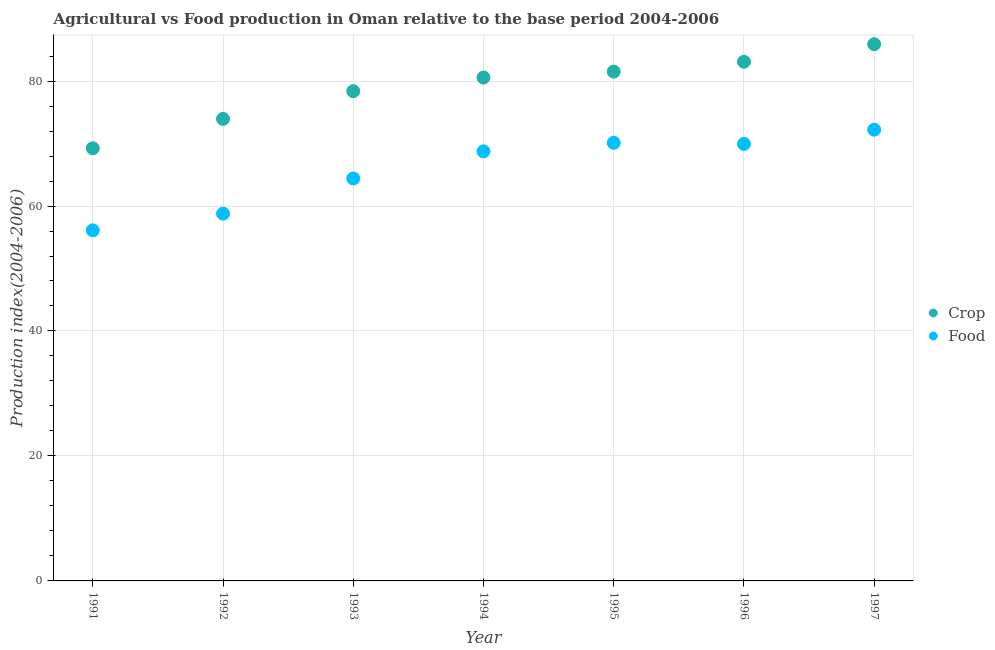How many different coloured dotlines are there?
Offer a terse response. 2. What is the food production index in 1996?
Give a very brief answer. 69.94. Across all years, what is the maximum food production index?
Offer a very short reply. 72.22. Across all years, what is the minimum crop production index?
Provide a succinct answer. 69.24. In which year was the food production index maximum?
Keep it short and to the point. 1997. What is the total crop production index in the graph?
Provide a succinct answer. 552.62. What is the difference between the crop production index in 1995 and that in 1997?
Your answer should be compact. -4.39. What is the difference between the food production index in 1994 and the crop production index in 1995?
Provide a short and direct response. -12.76. What is the average food production index per year?
Offer a terse response. 65.76. In the year 1995, what is the difference between the food production index and crop production index?
Ensure brevity in your answer.  -11.39. What is the ratio of the crop production index in 1993 to that in 1995?
Your answer should be very brief. 0.96. Is the crop production index in 1992 less than that in 1997?
Provide a succinct answer. Yes. Is the difference between the food production index in 1991 and 1992 greater than the difference between the crop production index in 1991 and 1992?
Make the answer very short. Yes. What is the difference between the highest and the second highest crop production index?
Ensure brevity in your answer.  2.81. What is the difference between the highest and the lowest food production index?
Keep it short and to the point. 16.11. Does the crop production index monotonically increase over the years?
Your answer should be compact. Yes. Is the crop production index strictly less than the food production index over the years?
Your answer should be compact. No. How many dotlines are there?
Your answer should be very brief. 2. How many legend labels are there?
Ensure brevity in your answer.  2. What is the title of the graph?
Offer a terse response. Agricultural vs Food production in Oman relative to the base period 2004-2006. What is the label or title of the Y-axis?
Your answer should be very brief. Production index(2004-2006). What is the Production index(2004-2006) of Crop in 1991?
Provide a succinct answer. 69.24. What is the Production index(2004-2006) in Food in 1991?
Your answer should be very brief. 56.11. What is the Production index(2004-2006) in Crop in 1992?
Your answer should be very brief. 73.94. What is the Production index(2004-2006) of Food in 1992?
Provide a succinct answer. 58.78. What is the Production index(2004-2006) of Crop in 1993?
Ensure brevity in your answer.  78.38. What is the Production index(2004-2006) of Food in 1993?
Make the answer very short. 64.41. What is the Production index(2004-2006) in Crop in 1994?
Your answer should be very brief. 80.56. What is the Production index(2004-2006) of Food in 1994?
Provide a succinct answer. 68.75. What is the Production index(2004-2006) of Crop in 1995?
Ensure brevity in your answer.  81.51. What is the Production index(2004-2006) in Food in 1995?
Your answer should be compact. 70.12. What is the Production index(2004-2006) of Crop in 1996?
Your response must be concise. 83.09. What is the Production index(2004-2006) in Food in 1996?
Keep it short and to the point. 69.94. What is the Production index(2004-2006) in Crop in 1997?
Provide a short and direct response. 85.9. What is the Production index(2004-2006) of Food in 1997?
Offer a terse response. 72.22. Across all years, what is the maximum Production index(2004-2006) in Crop?
Make the answer very short. 85.9. Across all years, what is the maximum Production index(2004-2006) of Food?
Give a very brief answer. 72.22. Across all years, what is the minimum Production index(2004-2006) in Crop?
Give a very brief answer. 69.24. Across all years, what is the minimum Production index(2004-2006) of Food?
Ensure brevity in your answer.  56.11. What is the total Production index(2004-2006) of Crop in the graph?
Keep it short and to the point. 552.62. What is the total Production index(2004-2006) of Food in the graph?
Give a very brief answer. 460.33. What is the difference between the Production index(2004-2006) in Food in 1991 and that in 1992?
Ensure brevity in your answer.  -2.67. What is the difference between the Production index(2004-2006) of Crop in 1991 and that in 1993?
Your answer should be very brief. -9.14. What is the difference between the Production index(2004-2006) in Crop in 1991 and that in 1994?
Provide a succinct answer. -11.32. What is the difference between the Production index(2004-2006) in Food in 1991 and that in 1994?
Keep it short and to the point. -12.64. What is the difference between the Production index(2004-2006) of Crop in 1991 and that in 1995?
Your response must be concise. -12.27. What is the difference between the Production index(2004-2006) of Food in 1991 and that in 1995?
Your answer should be very brief. -14.01. What is the difference between the Production index(2004-2006) of Crop in 1991 and that in 1996?
Ensure brevity in your answer.  -13.85. What is the difference between the Production index(2004-2006) in Food in 1991 and that in 1996?
Your answer should be compact. -13.83. What is the difference between the Production index(2004-2006) in Crop in 1991 and that in 1997?
Offer a very short reply. -16.66. What is the difference between the Production index(2004-2006) of Food in 1991 and that in 1997?
Your response must be concise. -16.11. What is the difference between the Production index(2004-2006) of Crop in 1992 and that in 1993?
Make the answer very short. -4.44. What is the difference between the Production index(2004-2006) in Food in 1992 and that in 1993?
Provide a short and direct response. -5.63. What is the difference between the Production index(2004-2006) in Crop in 1992 and that in 1994?
Ensure brevity in your answer.  -6.62. What is the difference between the Production index(2004-2006) of Food in 1992 and that in 1994?
Your response must be concise. -9.97. What is the difference between the Production index(2004-2006) of Crop in 1992 and that in 1995?
Provide a short and direct response. -7.57. What is the difference between the Production index(2004-2006) of Food in 1992 and that in 1995?
Ensure brevity in your answer.  -11.34. What is the difference between the Production index(2004-2006) in Crop in 1992 and that in 1996?
Ensure brevity in your answer.  -9.15. What is the difference between the Production index(2004-2006) in Food in 1992 and that in 1996?
Provide a short and direct response. -11.16. What is the difference between the Production index(2004-2006) in Crop in 1992 and that in 1997?
Your response must be concise. -11.96. What is the difference between the Production index(2004-2006) of Food in 1992 and that in 1997?
Your answer should be very brief. -13.44. What is the difference between the Production index(2004-2006) in Crop in 1993 and that in 1994?
Offer a terse response. -2.18. What is the difference between the Production index(2004-2006) of Food in 1993 and that in 1994?
Offer a terse response. -4.34. What is the difference between the Production index(2004-2006) of Crop in 1993 and that in 1995?
Provide a succinct answer. -3.13. What is the difference between the Production index(2004-2006) of Food in 1993 and that in 1995?
Your response must be concise. -5.71. What is the difference between the Production index(2004-2006) of Crop in 1993 and that in 1996?
Ensure brevity in your answer.  -4.71. What is the difference between the Production index(2004-2006) of Food in 1993 and that in 1996?
Keep it short and to the point. -5.53. What is the difference between the Production index(2004-2006) of Crop in 1993 and that in 1997?
Offer a terse response. -7.52. What is the difference between the Production index(2004-2006) in Food in 1993 and that in 1997?
Your answer should be compact. -7.81. What is the difference between the Production index(2004-2006) in Crop in 1994 and that in 1995?
Keep it short and to the point. -0.95. What is the difference between the Production index(2004-2006) in Food in 1994 and that in 1995?
Offer a terse response. -1.37. What is the difference between the Production index(2004-2006) in Crop in 1994 and that in 1996?
Offer a terse response. -2.53. What is the difference between the Production index(2004-2006) in Food in 1994 and that in 1996?
Provide a succinct answer. -1.19. What is the difference between the Production index(2004-2006) in Crop in 1994 and that in 1997?
Make the answer very short. -5.34. What is the difference between the Production index(2004-2006) in Food in 1994 and that in 1997?
Keep it short and to the point. -3.47. What is the difference between the Production index(2004-2006) in Crop in 1995 and that in 1996?
Offer a very short reply. -1.58. What is the difference between the Production index(2004-2006) of Food in 1995 and that in 1996?
Offer a terse response. 0.18. What is the difference between the Production index(2004-2006) of Crop in 1995 and that in 1997?
Give a very brief answer. -4.39. What is the difference between the Production index(2004-2006) in Food in 1995 and that in 1997?
Offer a very short reply. -2.1. What is the difference between the Production index(2004-2006) of Crop in 1996 and that in 1997?
Your answer should be very brief. -2.81. What is the difference between the Production index(2004-2006) in Food in 1996 and that in 1997?
Make the answer very short. -2.28. What is the difference between the Production index(2004-2006) of Crop in 1991 and the Production index(2004-2006) of Food in 1992?
Offer a terse response. 10.46. What is the difference between the Production index(2004-2006) in Crop in 1991 and the Production index(2004-2006) in Food in 1993?
Keep it short and to the point. 4.83. What is the difference between the Production index(2004-2006) of Crop in 1991 and the Production index(2004-2006) of Food in 1994?
Provide a short and direct response. 0.49. What is the difference between the Production index(2004-2006) in Crop in 1991 and the Production index(2004-2006) in Food in 1995?
Offer a terse response. -0.88. What is the difference between the Production index(2004-2006) of Crop in 1991 and the Production index(2004-2006) of Food in 1997?
Make the answer very short. -2.98. What is the difference between the Production index(2004-2006) in Crop in 1992 and the Production index(2004-2006) in Food in 1993?
Keep it short and to the point. 9.53. What is the difference between the Production index(2004-2006) of Crop in 1992 and the Production index(2004-2006) of Food in 1994?
Your response must be concise. 5.19. What is the difference between the Production index(2004-2006) in Crop in 1992 and the Production index(2004-2006) in Food in 1995?
Your response must be concise. 3.82. What is the difference between the Production index(2004-2006) in Crop in 1992 and the Production index(2004-2006) in Food in 1996?
Offer a very short reply. 4. What is the difference between the Production index(2004-2006) in Crop in 1992 and the Production index(2004-2006) in Food in 1997?
Offer a terse response. 1.72. What is the difference between the Production index(2004-2006) of Crop in 1993 and the Production index(2004-2006) of Food in 1994?
Make the answer very short. 9.63. What is the difference between the Production index(2004-2006) of Crop in 1993 and the Production index(2004-2006) of Food in 1995?
Your answer should be compact. 8.26. What is the difference between the Production index(2004-2006) of Crop in 1993 and the Production index(2004-2006) of Food in 1996?
Provide a succinct answer. 8.44. What is the difference between the Production index(2004-2006) in Crop in 1993 and the Production index(2004-2006) in Food in 1997?
Give a very brief answer. 6.16. What is the difference between the Production index(2004-2006) in Crop in 1994 and the Production index(2004-2006) in Food in 1995?
Make the answer very short. 10.44. What is the difference between the Production index(2004-2006) of Crop in 1994 and the Production index(2004-2006) of Food in 1996?
Ensure brevity in your answer.  10.62. What is the difference between the Production index(2004-2006) in Crop in 1994 and the Production index(2004-2006) in Food in 1997?
Provide a short and direct response. 8.34. What is the difference between the Production index(2004-2006) of Crop in 1995 and the Production index(2004-2006) of Food in 1996?
Ensure brevity in your answer.  11.57. What is the difference between the Production index(2004-2006) of Crop in 1995 and the Production index(2004-2006) of Food in 1997?
Your response must be concise. 9.29. What is the difference between the Production index(2004-2006) in Crop in 1996 and the Production index(2004-2006) in Food in 1997?
Offer a terse response. 10.87. What is the average Production index(2004-2006) of Crop per year?
Offer a terse response. 78.95. What is the average Production index(2004-2006) in Food per year?
Offer a very short reply. 65.76. In the year 1991, what is the difference between the Production index(2004-2006) of Crop and Production index(2004-2006) of Food?
Make the answer very short. 13.13. In the year 1992, what is the difference between the Production index(2004-2006) in Crop and Production index(2004-2006) in Food?
Offer a terse response. 15.16. In the year 1993, what is the difference between the Production index(2004-2006) of Crop and Production index(2004-2006) of Food?
Your answer should be very brief. 13.97. In the year 1994, what is the difference between the Production index(2004-2006) in Crop and Production index(2004-2006) in Food?
Make the answer very short. 11.81. In the year 1995, what is the difference between the Production index(2004-2006) in Crop and Production index(2004-2006) in Food?
Your response must be concise. 11.39. In the year 1996, what is the difference between the Production index(2004-2006) of Crop and Production index(2004-2006) of Food?
Provide a short and direct response. 13.15. In the year 1997, what is the difference between the Production index(2004-2006) of Crop and Production index(2004-2006) of Food?
Your answer should be compact. 13.68. What is the ratio of the Production index(2004-2006) of Crop in 1991 to that in 1992?
Ensure brevity in your answer.  0.94. What is the ratio of the Production index(2004-2006) in Food in 1991 to that in 1992?
Make the answer very short. 0.95. What is the ratio of the Production index(2004-2006) of Crop in 1991 to that in 1993?
Your answer should be compact. 0.88. What is the ratio of the Production index(2004-2006) of Food in 1991 to that in 1993?
Provide a short and direct response. 0.87. What is the ratio of the Production index(2004-2006) in Crop in 1991 to that in 1994?
Give a very brief answer. 0.86. What is the ratio of the Production index(2004-2006) of Food in 1991 to that in 1994?
Make the answer very short. 0.82. What is the ratio of the Production index(2004-2006) in Crop in 1991 to that in 1995?
Keep it short and to the point. 0.85. What is the ratio of the Production index(2004-2006) in Food in 1991 to that in 1995?
Offer a very short reply. 0.8. What is the ratio of the Production index(2004-2006) of Crop in 1991 to that in 1996?
Your answer should be very brief. 0.83. What is the ratio of the Production index(2004-2006) in Food in 1991 to that in 1996?
Offer a terse response. 0.8. What is the ratio of the Production index(2004-2006) of Crop in 1991 to that in 1997?
Offer a very short reply. 0.81. What is the ratio of the Production index(2004-2006) of Food in 1991 to that in 1997?
Make the answer very short. 0.78. What is the ratio of the Production index(2004-2006) in Crop in 1992 to that in 1993?
Offer a very short reply. 0.94. What is the ratio of the Production index(2004-2006) in Food in 1992 to that in 1993?
Provide a short and direct response. 0.91. What is the ratio of the Production index(2004-2006) in Crop in 1992 to that in 1994?
Your response must be concise. 0.92. What is the ratio of the Production index(2004-2006) in Food in 1992 to that in 1994?
Keep it short and to the point. 0.85. What is the ratio of the Production index(2004-2006) in Crop in 1992 to that in 1995?
Your response must be concise. 0.91. What is the ratio of the Production index(2004-2006) in Food in 1992 to that in 1995?
Provide a succinct answer. 0.84. What is the ratio of the Production index(2004-2006) of Crop in 1992 to that in 1996?
Give a very brief answer. 0.89. What is the ratio of the Production index(2004-2006) in Food in 1992 to that in 1996?
Provide a short and direct response. 0.84. What is the ratio of the Production index(2004-2006) of Crop in 1992 to that in 1997?
Keep it short and to the point. 0.86. What is the ratio of the Production index(2004-2006) in Food in 1992 to that in 1997?
Your answer should be very brief. 0.81. What is the ratio of the Production index(2004-2006) of Crop in 1993 to that in 1994?
Give a very brief answer. 0.97. What is the ratio of the Production index(2004-2006) of Food in 1993 to that in 1994?
Keep it short and to the point. 0.94. What is the ratio of the Production index(2004-2006) in Crop in 1993 to that in 1995?
Ensure brevity in your answer.  0.96. What is the ratio of the Production index(2004-2006) of Food in 1993 to that in 1995?
Your response must be concise. 0.92. What is the ratio of the Production index(2004-2006) of Crop in 1993 to that in 1996?
Offer a terse response. 0.94. What is the ratio of the Production index(2004-2006) of Food in 1993 to that in 1996?
Your answer should be compact. 0.92. What is the ratio of the Production index(2004-2006) of Crop in 1993 to that in 1997?
Your answer should be compact. 0.91. What is the ratio of the Production index(2004-2006) in Food in 1993 to that in 1997?
Your answer should be compact. 0.89. What is the ratio of the Production index(2004-2006) in Crop in 1994 to that in 1995?
Offer a very short reply. 0.99. What is the ratio of the Production index(2004-2006) in Food in 1994 to that in 1995?
Your response must be concise. 0.98. What is the ratio of the Production index(2004-2006) of Crop in 1994 to that in 1996?
Your answer should be very brief. 0.97. What is the ratio of the Production index(2004-2006) of Crop in 1994 to that in 1997?
Provide a succinct answer. 0.94. What is the ratio of the Production index(2004-2006) in Food in 1994 to that in 1997?
Offer a terse response. 0.95. What is the ratio of the Production index(2004-2006) of Food in 1995 to that in 1996?
Provide a short and direct response. 1. What is the ratio of the Production index(2004-2006) of Crop in 1995 to that in 1997?
Keep it short and to the point. 0.95. What is the ratio of the Production index(2004-2006) of Food in 1995 to that in 1997?
Your answer should be compact. 0.97. What is the ratio of the Production index(2004-2006) in Crop in 1996 to that in 1997?
Your response must be concise. 0.97. What is the ratio of the Production index(2004-2006) in Food in 1996 to that in 1997?
Provide a succinct answer. 0.97. What is the difference between the highest and the second highest Production index(2004-2006) in Crop?
Your answer should be very brief. 2.81. What is the difference between the highest and the lowest Production index(2004-2006) in Crop?
Make the answer very short. 16.66. What is the difference between the highest and the lowest Production index(2004-2006) in Food?
Ensure brevity in your answer.  16.11. 